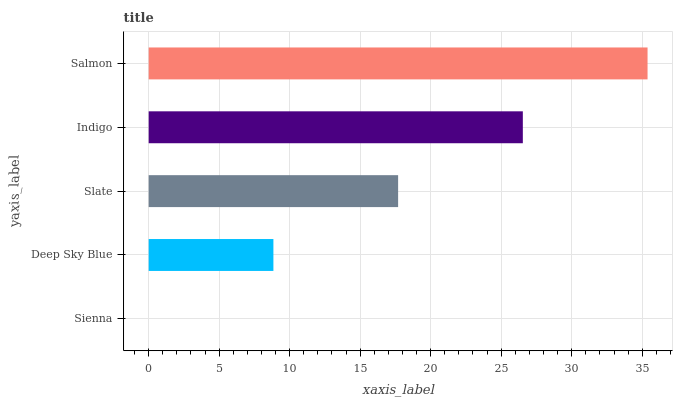Is Sienna the minimum?
Answer yes or no. Yes. Is Salmon the maximum?
Answer yes or no. Yes. Is Deep Sky Blue the minimum?
Answer yes or no. No. Is Deep Sky Blue the maximum?
Answer yes or no. No. Is Deep Sky Blue greater than Sienna?
Answer yes or no. Yes. Is Sienna less than Deep Sky Blue?
Answer yes or no. Yes. Is Sienna greater than Deep Sky Blue?
Answer yes or no. No. Is Deep Sky Blue less than Sienna?
Answer yes or no. No. Is Slate the high median?
Answer yes or no. Yes. Is Slate the low median?
Answer yes or no. Yes. Is Sienna the high median?
Answer yes or no. No. Is Deep Sky Blue the low median?
Answer yes or no. No. 